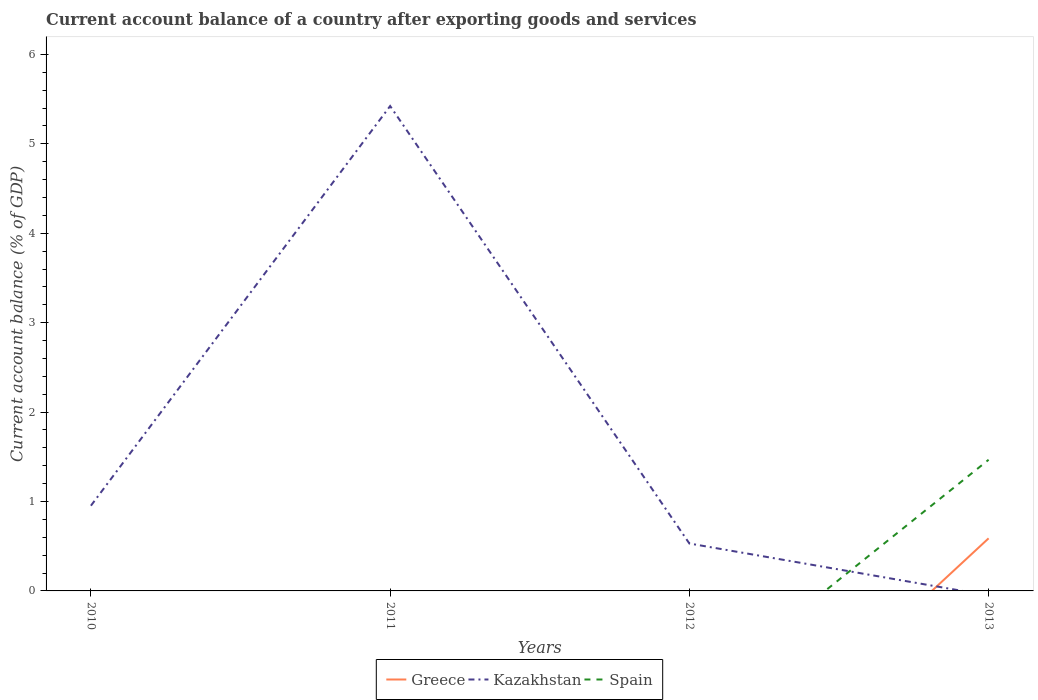How many different coloured lines are there?
Keep it short and to the point. 3. Does the line corresponding to Spain intersect with the line corresponding to Kazakhstan?
Offer a very short reply. Yes. Is the number of lines equal to the number of legend labels?
Your answer should be compact. No. What is the total account balance in Kazakhstan in the graph?
Make the answer very short. -4.47. What is the difference between the highest and the second highest account balance in Kazakhstan?
Keep it short and to the point. 5.42. Is the account balance in Kazakhstan strictly greater than the account balance in Greece over the years?
Your answer should be compact. No. How many years are there in the graph?
Your answer should be compact. 4. Are the values on the major ticks of Y-axis written in scientific E-notation?
Offer a terse response. No. Does the graph contain grids?
Your answer should be compact. No. Where does the legend appear in the graph?
Keep it short and to the point. Bottom center. How many legend labels are there?
Offer a very short reply. 3. What is the title of the graph?
Provide a short and direct response. Current account balance of a country after exporting goods and services. What is the label or title of the Y-axis?
Your answer should be compact. Current account balance (% of GDP). What is the Current account balance (% of GDP) in Kazakhstan in 2010?
Ensure brevity in your answer.  0.95. What is the Current account balance (% of GDP) of Spain in 2010?
Give a very brief answer. 0. What is the Current account balance (% of GDP) of Kazakhstan in 2011?
Offer a terse response. 5.42. What is the Current account balance (% of GDP) in Spain in 2011?
Keep it short and to the point. 0. What is the Current account balance (% of GDP) in Greece in 2012?
Offer a terse response. 0. What is the Current account balance (% of GDP) in Kazakhstan in 2012?
Offer a very short reply. 0.53. What is the Current account balance (% of GDP) of Greece in 2013?
Provide a short and direct response. 0.59. What is the Current account balance (% of GDP) of Kazakhstan in 2013?
Make the answer very short. 0. What is the Current account balance (% of GDP) in Spain in 2013?
Your answer should be compact. 1.47. Across all years, what is the maximum Current account balance (% of GDP) of Greece?
Offer a very short reply. 0.59. Across all years, what is the maximum Current account balance (% of GDP) in Kazakhstan?
Give a very brief answer. 5.42. Across all years, what is the maximum Current account balance (% of GDP) of Spain?
Offer a terse response. 1.47. Across all years, what is the minimum Current account balance (% of GDP) in Greece?
Make the answer very short. 0. Across all years, what is the minimum Current account balance (% of GDP) of Kazakhstan?
Keep it short and to the point. 0. Across all years, what is the minimum Current account balance (% of GDP) of Spain?
Provide a short and direct response. 0. What is the total Current account balance (% of GDP) of Greece in the graph?
Provide a short and direct response. 0.59. What is the total Current account balance (% of GDP) in Kazakhstan in the graph?
Ensure brevity in your answer.  6.91. What is the total Current account balance (% of GDP) of Spain in the graph?
Ensure brevity in your answer.  1.47. What is the difference between the Current account balance (% of GDP) in Kazakhstan in 2010 and that in 2011?
Your response must be concise. -4.47. What is the difference between the Current account balance (% of GDP) of Kazakhstan in 2010 and that in 2012?
Give a very brief answer. 0.42. What is the difference between the Current account balance (% of GDP) of Kazakhstan in 2011 and that in 2012?
Your response must be concise. 4.89. What is the difference between the Current account balance (% of GDP) in Kazakhstan in 2010 and the Current account balance (% of GDP) in Spain in 2013?
Provide a succinct answer. -0.51. What is the difference between the Current account balance (% of GDP) of Kazakhstan in 2011 and the Current account balance (% of GDP) of Spain in 2013?
Offer a very short reply. 3.96. What is the difference between the Current account balance (% of GDP) of Kazakhstan in 2012 and the Current account balance (% of GDP) of Spain in 2013?
Make the answer very short. -0.94. What is the average Current account balance (% of GDP) of Greece per year?
Make the answer very short. 0.15. What is the average Current account balance (% of GDP) of Kazakhstan per year?
Your answer should be compact. 1.73. What is the average Current account balance (% of GDP) in Spain per year?
Offer a terse response. 0.37. In the year 2013, what is the difference between the Current account balance (% of GDP) in Greece and Current account balance (% of GDP) in Spain?
Offer a terse response. -0.88. What is the ratio of the Current account balance (% of GDP) in Kazakhstan in 2010 to that in 2011?
Offer a terse response. 0.18. What is the ratio of the Current account balance (% of GDP) of Kazakhstan in 2010 to that in 2012?
Provide a short and direct response. 1.8. What is the ratio of the Current account balance (% of GDP) of Kazakhstan in 2011 to that in 2012?
Ensure brevity in your answer.  10.23. What is the difference between the highest and the second highest Current account balance (% of GDP) in Kazakhstan?
Give a very brief answer. 4.47. What is the difference between the highest and the lowest Current account balance (% of GDP) of Greece?
Give a very brief answer. 0.59. What is the difference between the highest and the lowest Current account balance (% of GDP) in Kazakhstan?
Offer a terse response. 5.42. What is the difference between the highest and the lowest Current account balance (% of GDP) in Spain?
Your answer should be very brief. 1.47. 